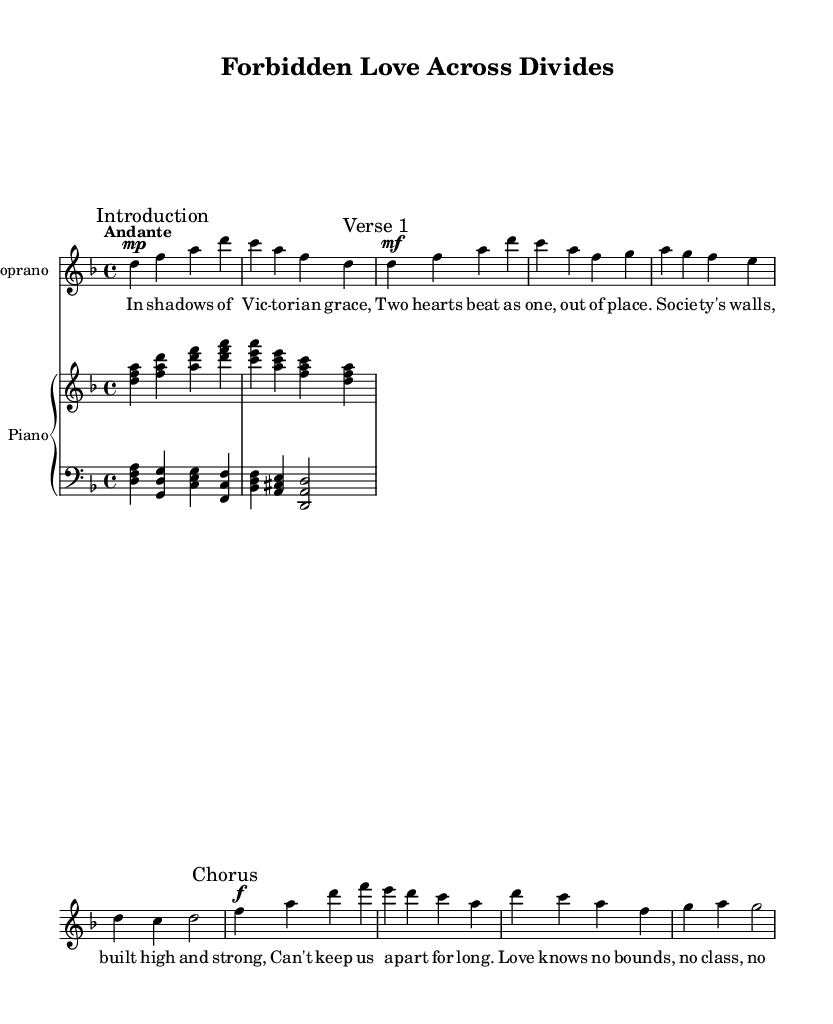What is the key signature of this music? The key signature is indicated at the beginning of the music, showing one flat which represents B flat. This means the piece is in D minor.
Answer: D minor What is the time signature of this piece? The time signature is found next to the key signature at the beginning of the sheet music and indicates the grouping of beats, which is four beats per measure.
Answer: 4/4 What is the tempo marking for this opera? The tempo marking is identified in the score, showing that the piece is meant to be played at a moderate speed, specifically described as "Andante."
Answer: Andante How many measures are in the introduction? Counting the measures in the introduction segment of the music, we find that it consists of four measures before transitioning to the verse.
Answer: 4 What dynamic marking is indicated for the chorus? The dynamic marking is indicated before the chorus section, specifying how loudly or softly the music is to be played, which in this case is marked as forte.
Answer: Forte Which themes are explored in the lyrics? The lyrics express themes of love and the obstacles presented by social divides, highlighting the emotional struggles of the characters. This is reflected in phrases about forbidden love and societal restrictions.
Answer: Love and social class 